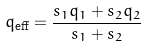Convert formula to latex. <formula><loc_0><loc_0><loc_500><loc_500>q _ { \text {eff} } = \frac { s _ { 1 } q _ { 1 } + s _ { 2 } q _ { 2 } } { s _ { 1 } + s _ { 2 } }</formula> 